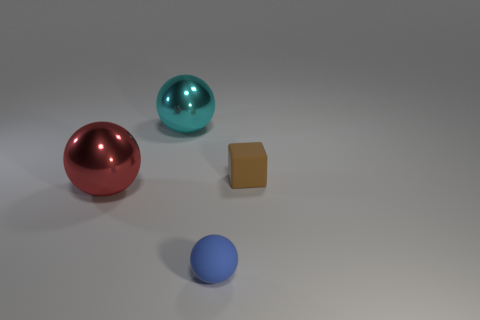How many objects are in the image and can you describe their positions relative to each other? There are four objects in the image: three spheres and one cube. The largest red sphere is positioned to the left, the medium-sized teal sphere is in the middle, and the small blue sphere is near the bottom right. The cube is on the right side and sits between the teal sphere and the small blue sphere, closer to the foreground than the spheres. 